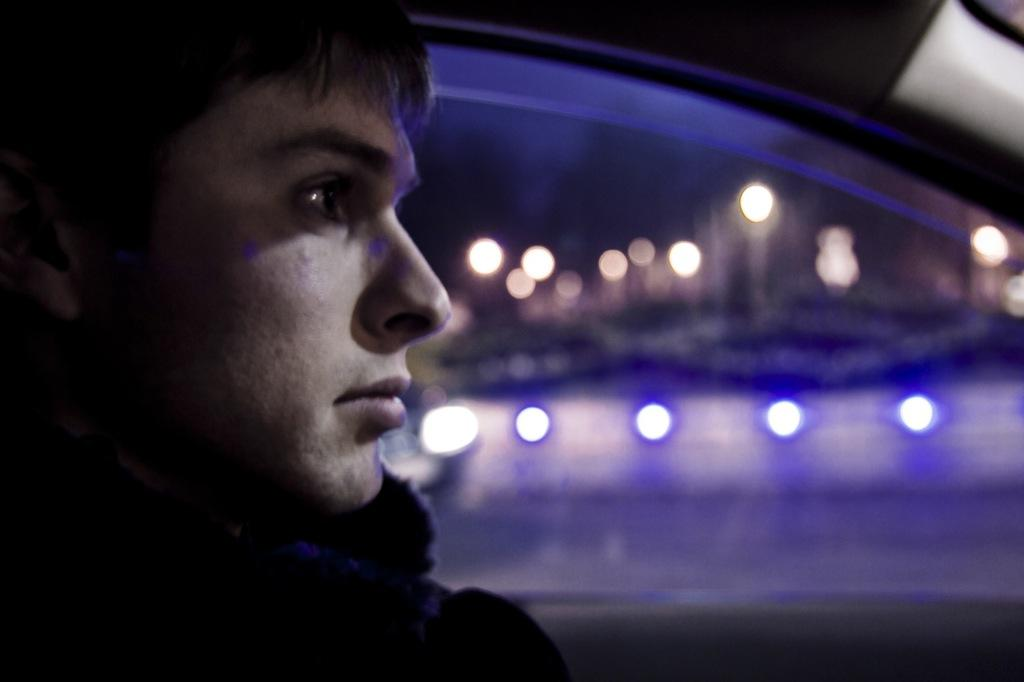What is the man in the image doing? The man is sitting in a car. Can you describe the background of the image? There are lights visible in the background of the image. What type of copy is the man reading in the car? There is no copy present in the image, as the man is simply sitting in the car. 